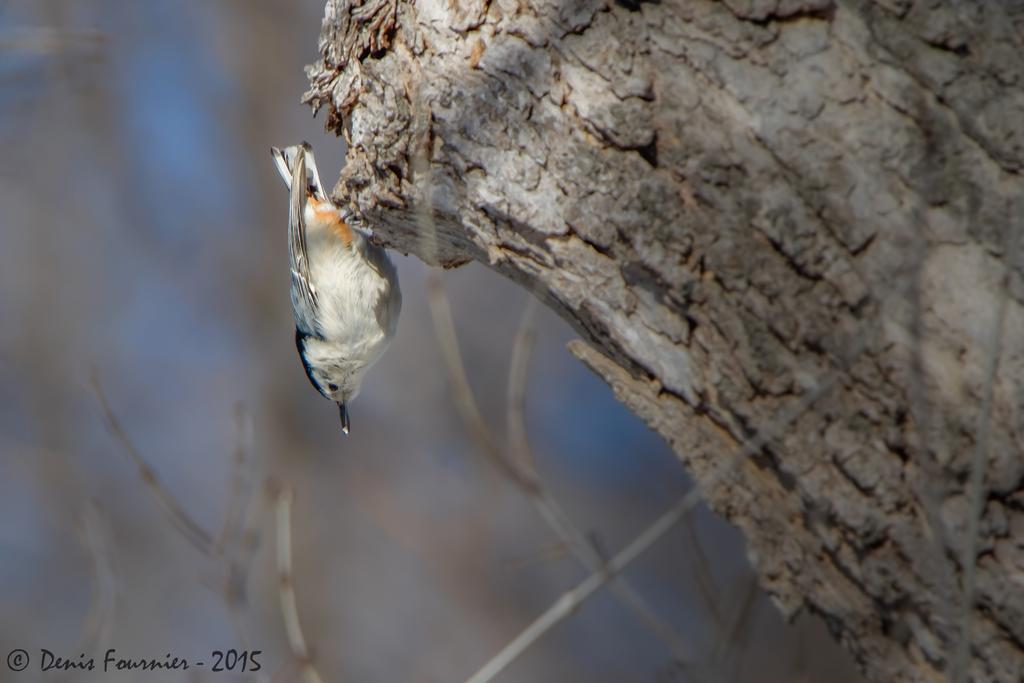Describe this image in one or two sentences. In this image I can see a bird, the bird is in white and black color, and the bird is standing on the trunk, and I can see blurred background. 